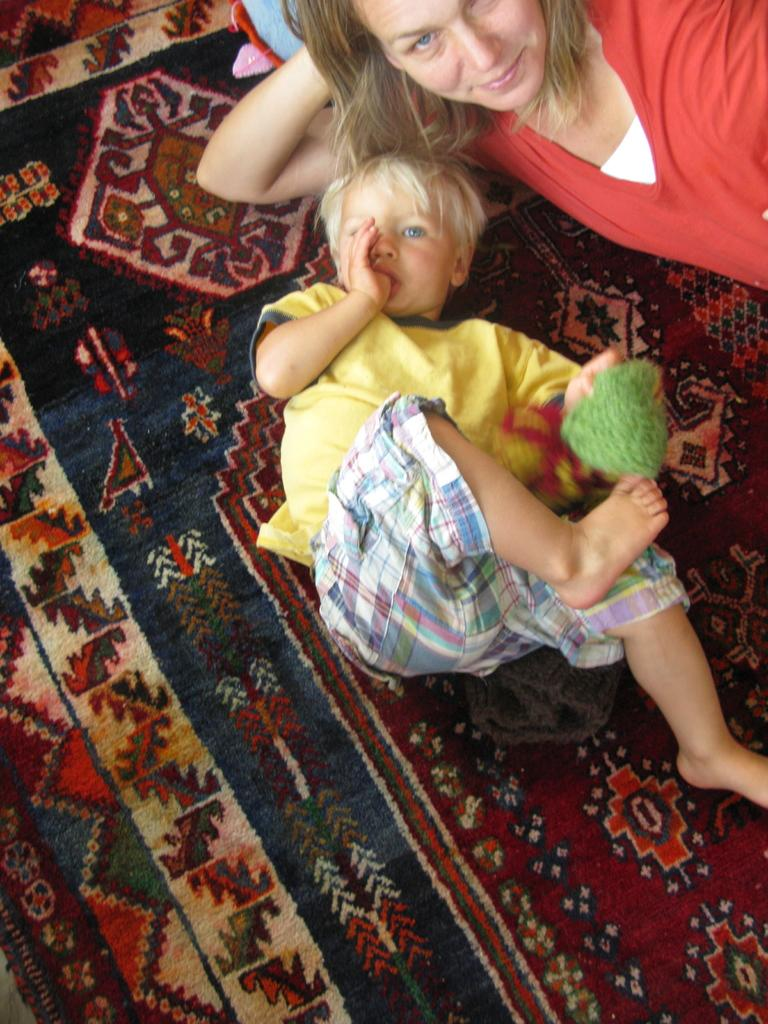Who are the people in the image? There is a woman and a boy in the image. What is the boy doing in the image? The boy is holding an object in the image. What position are the woman and the boy in? Both the woman and the boy are laying on a surface in the image. What verse can be heard being recited in the library in the image? There is no library or verse recitation present in the image. What type of shoe is the boy wearing in the image? There is no shoe visible in the image; the boy is not wearing any footwear. 